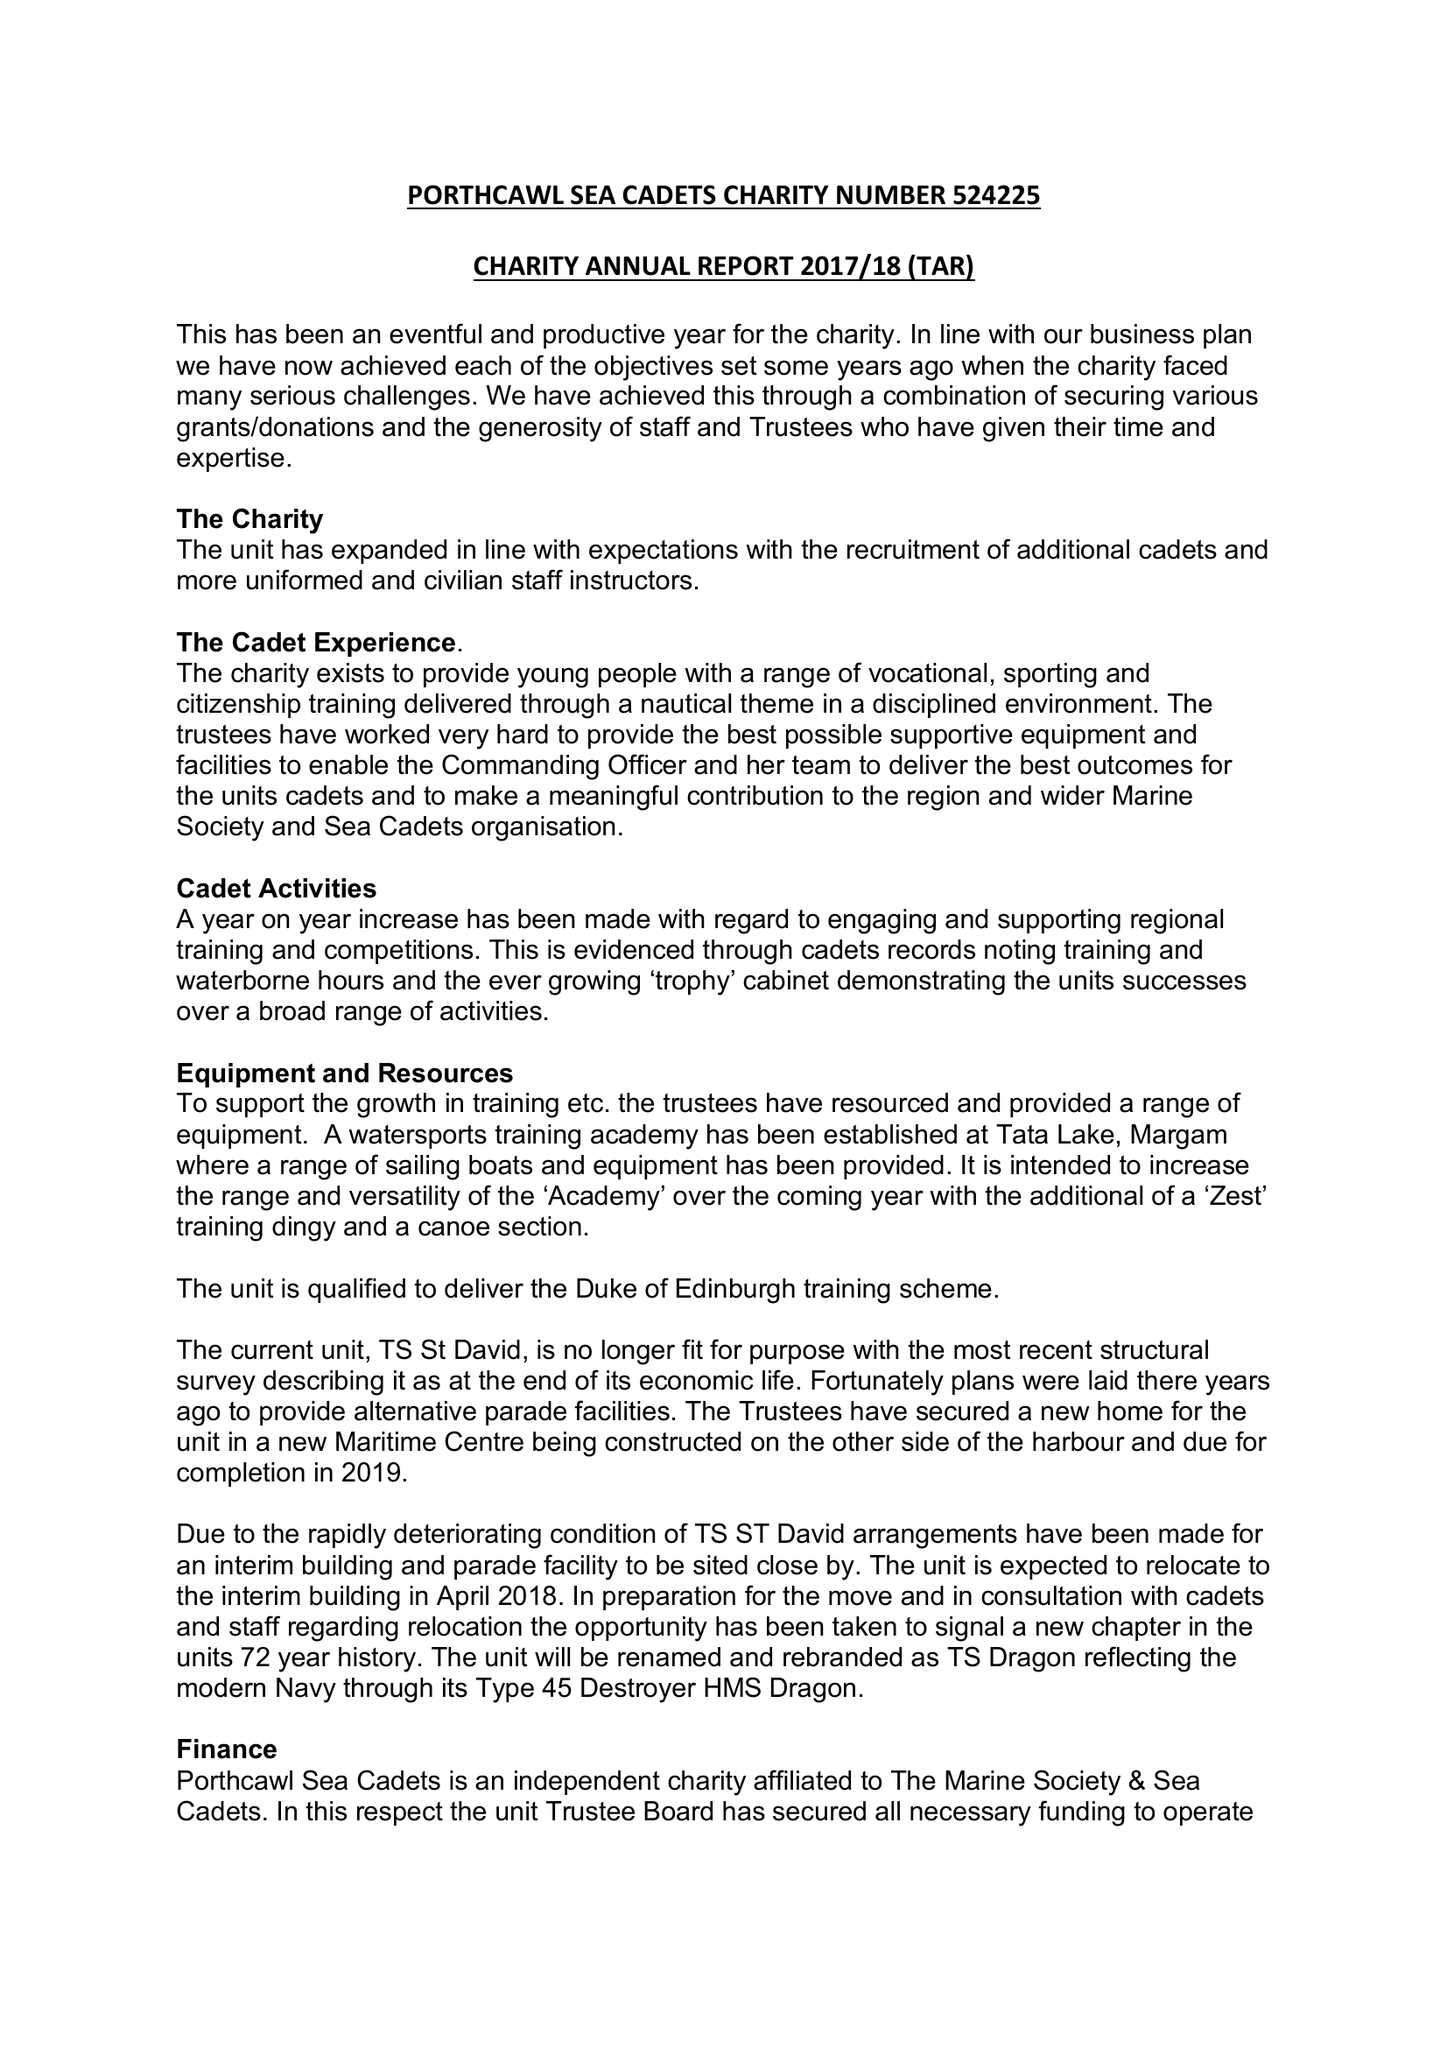What is the value for the report_date?
Answer the question using a single word or phrase. 2018-03-31 